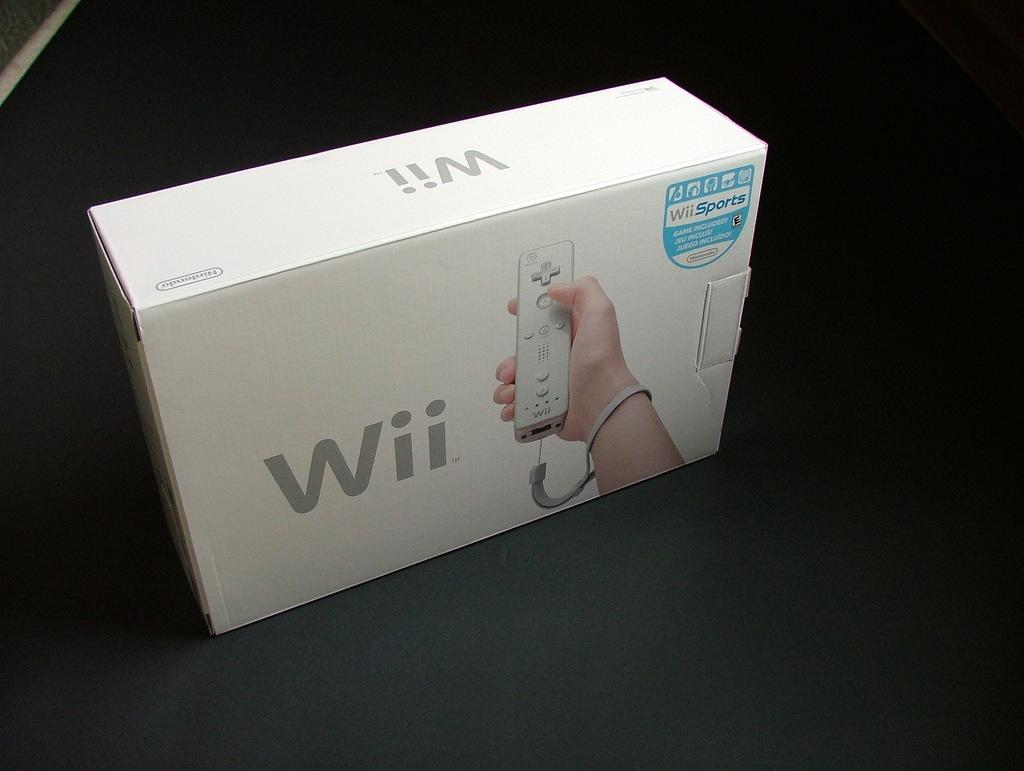What video game system is this?
Provide a succinct answer. Wii. What game is included?
Your response must be concise. Wii sports. 